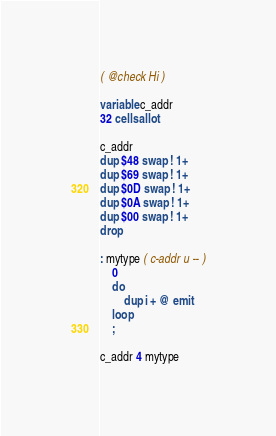<code> <loc_0><loc_0><loc_500><loc_500><_Forth_>( @check Hi )

variable c_addr
32 cells allot

c_addr
dup $48 swap ! 1+
dup $69 swap ! 1+
dup $0D swap ! 1+
dup $0A swap ! 1+
dup $00 swap ! 1+
drop

: mytype ( c-addr u -- )
    0
    do
        dup i + @ emit
    loop
    ;

c_addr 4 mytype
</code> 